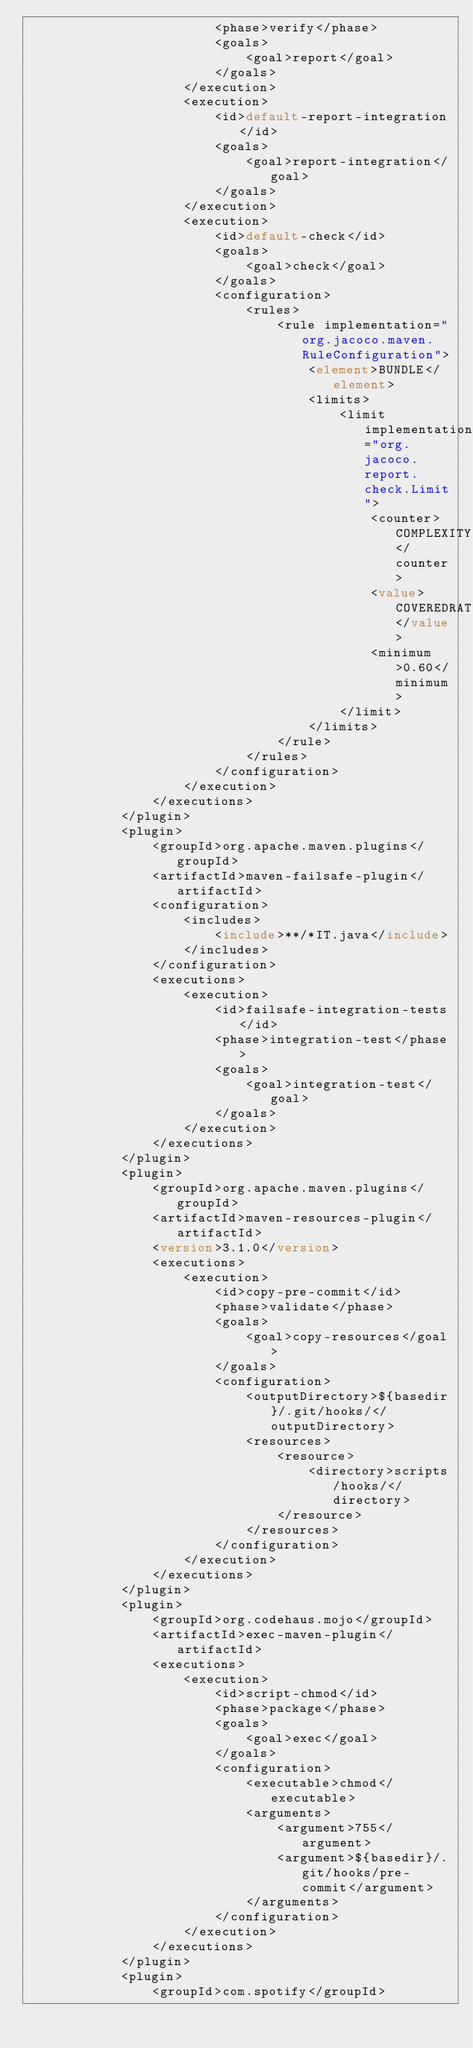Convert code to text. <code><loc_0><loc_0><loc_500><loc_500><_XML_>                        <phase>verify</phase>
                        <goals>
                            <goal>report</goal>
                        </goals>
                    </execution>
                    <execution>
                        <id>default-report-integration</id>
                        <goals>
                            <goal>report-integration</goal>
                        </goals>
                    </execution>
                    <execution>
                        <id>default-check</id>
                        <goals>
                            <goal>check</goal>
                        </goals>
                        <configuration>
                            <rules>
                                <rule implementation="org.jacoco.maven.RuleConfiguration">
                                    <element>BUNDLE</element>
                                    <limits>
                                        <limit implementation="org.jacoco.report.check.Limit">
                                            <counter>COMPLEXITY</counter>
                                            <value>COVEREDRATIO</value>
                                            <minimum>0.60</minimum>
                                        </limit>
                                    </limits>
                                </rule>
                            </rules>
                        </configuration>
                    </execution>
                </executions>
            </plugin>
            <plugin>
                <groupId>org.apache.maven.plugins</groupId>
                <artifactId>maven-failsafe-plugin</artifactId>
                <configuration>
                    <includes>
                        <include>**/*IT.java</include>
                    </includes>
                </configuration>
                <executions>
                    <execution>
                        <id>failsafe-integration-tests</id>
                        <phase>integration-test</phase>
                        <goals>
                            <goal>integration-test</goal>
                        </goals>
                    </execution>
                </executions>
            </plugin>
            <plugin>
                <groupId>org.apache.maven.plugins</groupId>
                <artifactId>maven-resources-plugin</artifactId>
                <version>3.1.0</version>
                <executions>
                    <execution>
                        <id>copy-pre-commit</id>
                        <phase>validate</phase>
                        <goals>
                            <goal>copy-resources</goal>
                        </goals>
                        <configuration>
                            <outputDirectory>${basedir}/.git/hooks/</outputDirectory>
                            <resources>
                                <resource>
                                    <directory>scripts/hooks/</directory>
                                </resource>
                            </resources>
                        </configuration>
                    </execution>
                </executions>
            </plugin>
            <plugin>
                <groupId>org.codehaus.mojo</groupId>
                <artifactId>exec-maven-plugin</artifactId>
                <executions>
                    <execution>
                        <id>script-chmod</id>
                        <phase>package</phase>
                        <goals>
                            <goal>exec</goal>
                        </goals>
                        <configuration>
                            <executable>chmod</executable>
                            <arguments>
                                <argument>755</argument>
                                <argument>${basedir}/.git/hooks/pre-commit</argument>
                            </arguments>
                        </configuration>
                    </execution>
                </executions>
            </plugin>
            <plugin>
                <groupId>com.spotify</groupId></code> 